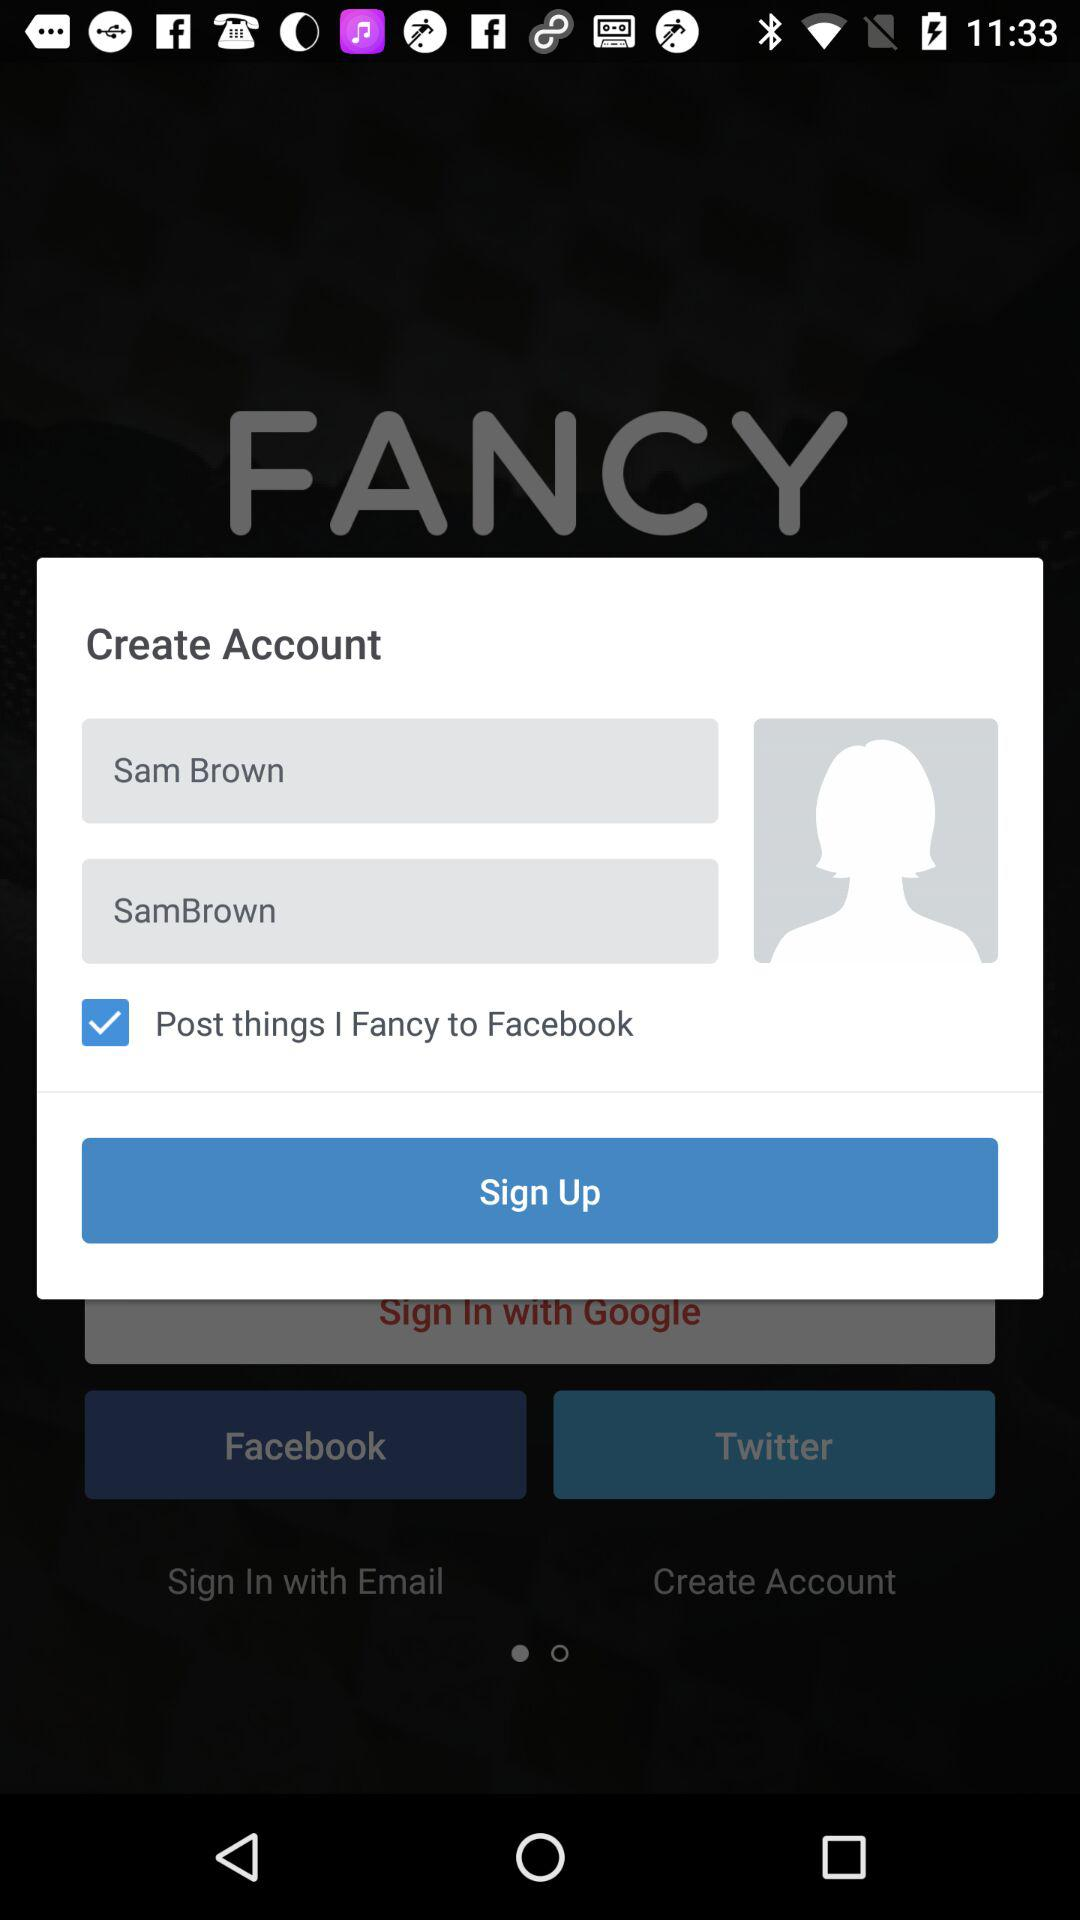What is the username? The username is SamBrown. 